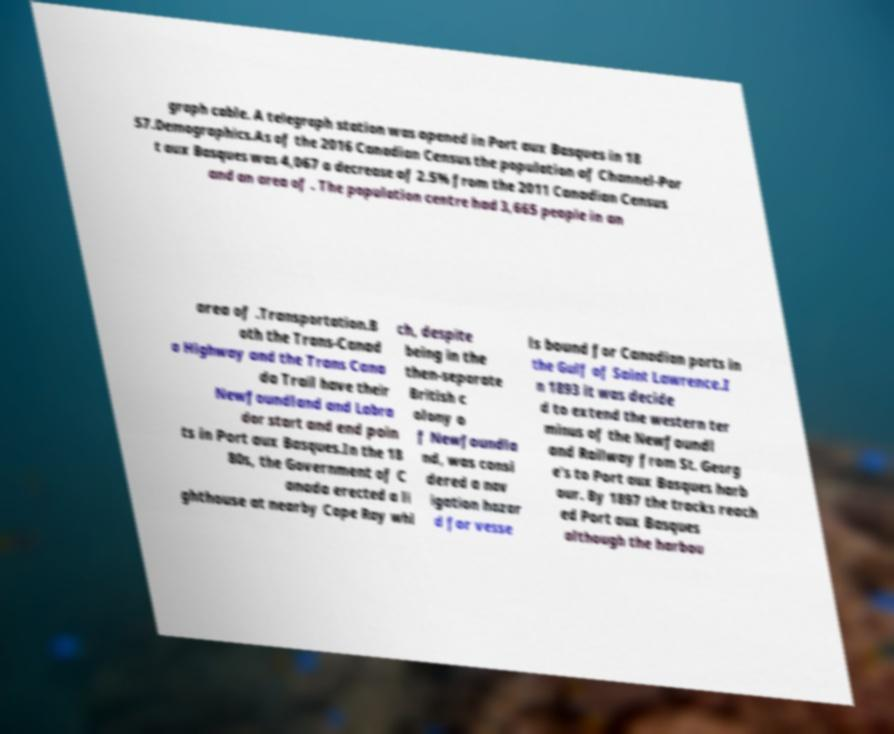There's text embedded in this image that I need extracted. Can you transcribe it verbatim? graph cable. A telegraph station was opened in Port aux Basques in 18 57.Demographics.As of the 2016 Canadian Census the population of Channel-Por t aux Basques was 4,067 a decrease of 2.5% from the 2011 Canadian Census and an area of . The population centre had 3,665 people in an area of .Transportation.B oth the Trans-Canad a Highway and the Trans Cana da Trail have their Newfoundland and Labra dor start and end poin ts in Port aux Basques.In the 18 80s, the Government of C anada erected a li ghthouse at nearby Cape Ray whi ch, despite being in the then-separate British c olony o f Newfoundla nd, was consi dered a nav igation hazar d for vesse ls bound for Canadian ports in the Gulf of Saint Lawrence.I n 1893 it was decide d to extend the western ter minus of the Newfoundl and Railway from St. Georg e's to Port aux Basques harb our. By 1897 the tracks reach ed Port aux Basques although the harbou 